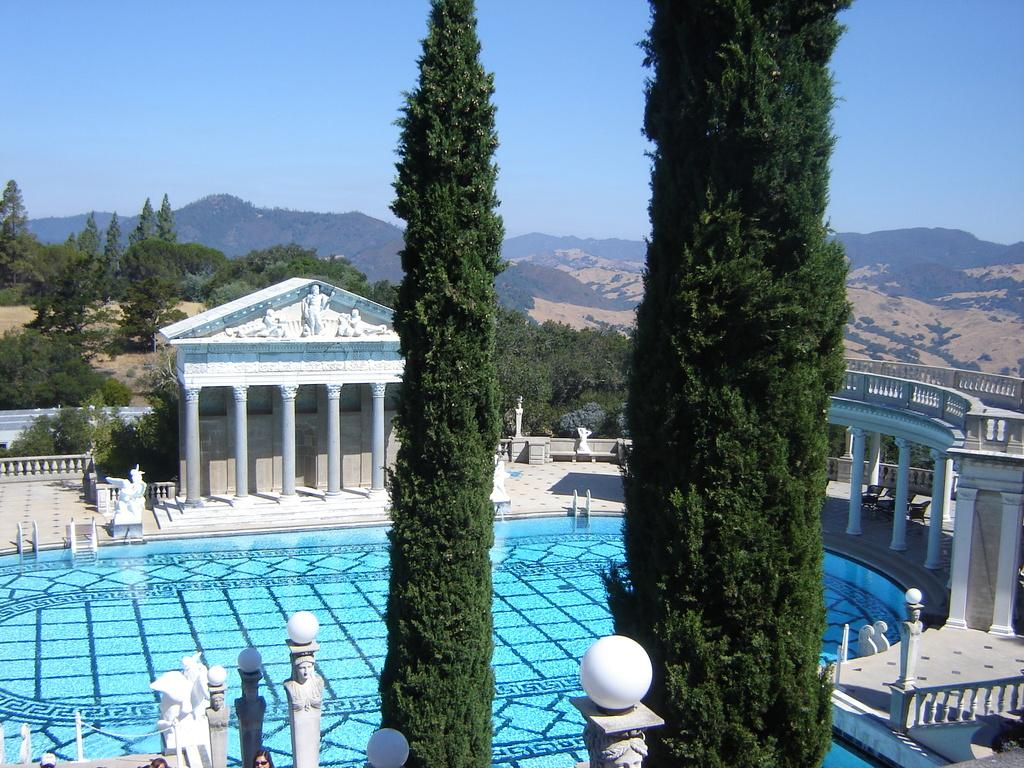How many big green trees are in the image? There are 2 big green trees in the image. What is the main feature of the image besides the trees? There is a swimming pool in the image. What can be seen at the top of the image? The sky is visible at the top of the image. What type of plane is flying over the trees in the image? There is no plane visible in the image; it only features 2 big green trees and a swimming pool. 